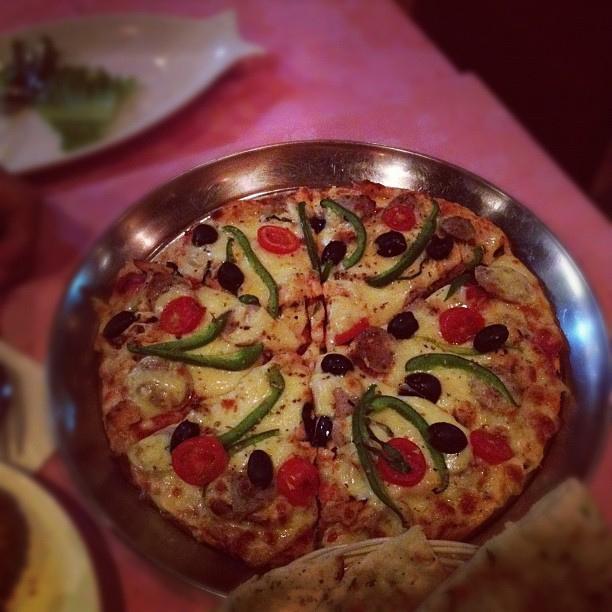How many people are holding tennis rackets?
Give a very brief answer. 0. 